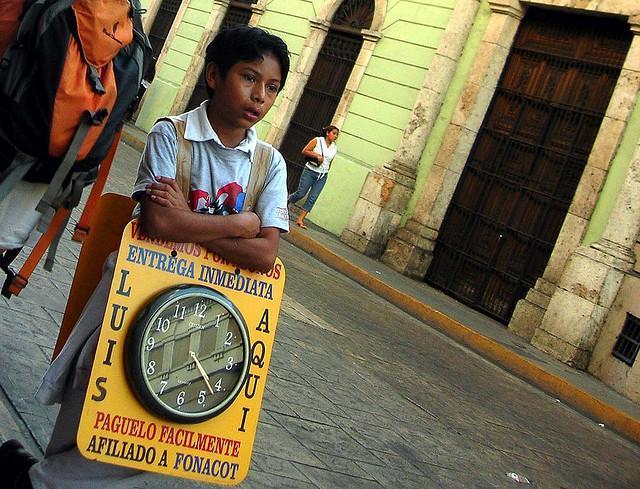How many people are there?
Give a very brief answer. 2. How many backpacks can you see?
Give a very brief answer. 2. 